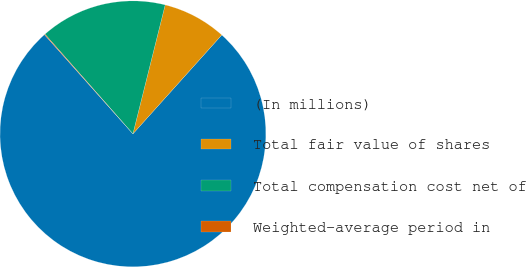Convert chart to OTSL. <chart><loc_0><loc_0><loc_500><loc_500><pie_chart><fcel>(In millions)<fcel>Total fair value of shares<fcel>Total compensation cost net of<fcel>Weighted-average period in<nl><fcel>76.76%<fcel>7.75%<fcel>15.41%<fcel>0.08%<nl></chart> 